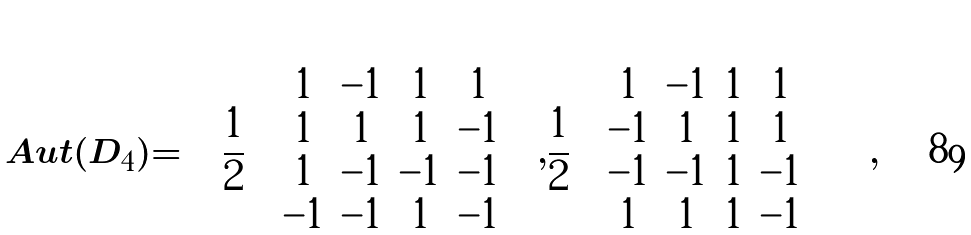Convert formula to latex. <formula><loc_0><loc_0><loc_500><loc_500>A u t ( D _ { 4 } ) = \left \langle \frac { 1 } { 2 } \left ( \begin{array} { c c c c } 1 & - 1 & 1 & 1 \\ 1 & 1 & 1 & - 1 \\ 1 & - 1 & - 1 & - 1 \\ - 1 & - 1 & 1 & - 1 \\ \end{array} \right ) , \frac { 1 } { 2 } \left ( \begin{array} { c c c c } 1 & - 1 & 1 & 1 \\ - 1 & 1 & 1 & 1 \\ - 1 & - 1 & 1 & - 1 \\ 1 & 1 & 1 & - 1 \\ \end{array} \right ) \right \rangle ,</formula> 